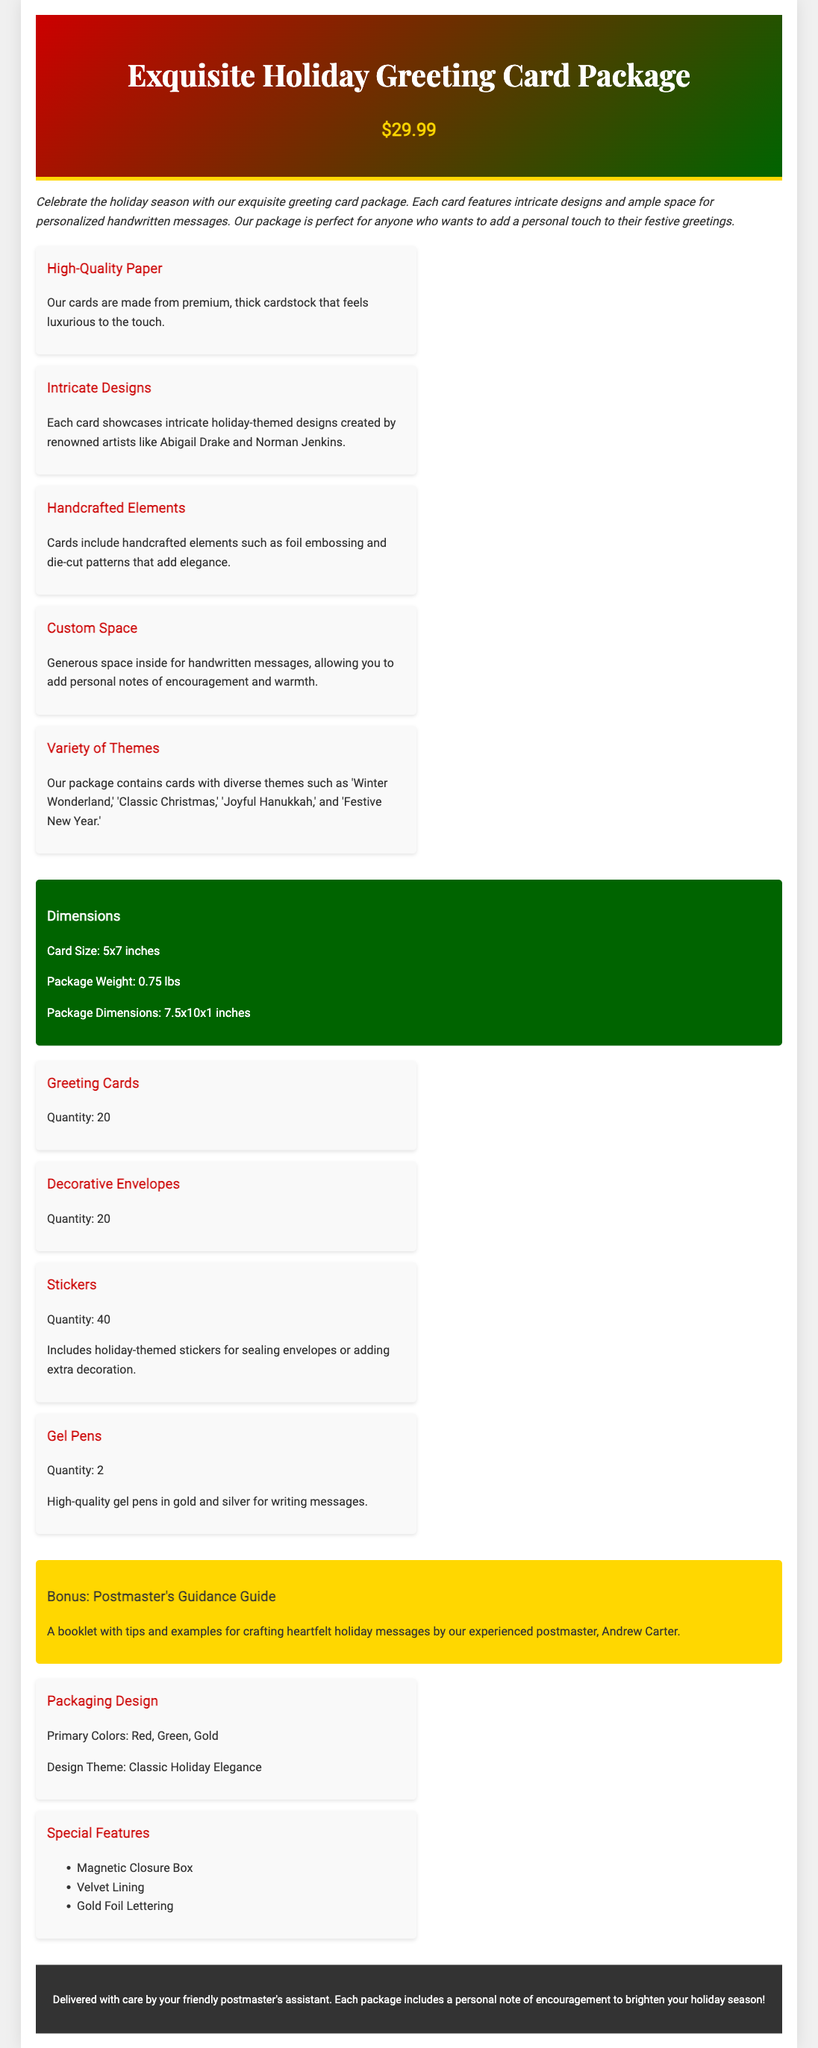What is the price of the greeting card package? The price is listed under the header section of the document as $29.99.
Answer: $29.99 How many greeting cards are included in the package? The quantity of greeting cards is specified in the inclusions section.
Answer: 20 What designs are featured on the cards? The section on features mentions they showcase intricate holiday-themed designs created by renowned artists.
Answer: Intricate holiday-themed designs What type of pens are included in the package? The inclusion section specifies the pens included as high-quality gel pens.
Answer: Gel pens What is the bonus item included in the package? The bonus item is mentioned at the end of the inclusions section as a guidance guide.
Answer: Postmaster's Guidance Guide What is the card size? The dimensions section provides the specific size of the cards as 5x7 inches.
Answer: 5x7 inches Which colors are used in the packaging design? The packaging section specifies the primary colors used as Red, Green, and Gold.
Answer: Red, Green, Gold Who authored the bonus guidance guide? The bonus section notes that the guidance guide is authored by Andrew Carter.
Answer: Andrew Carter How many stickers are included in the package? The inclusions section states the quantity of stickers included as 40.
Answer: 40 